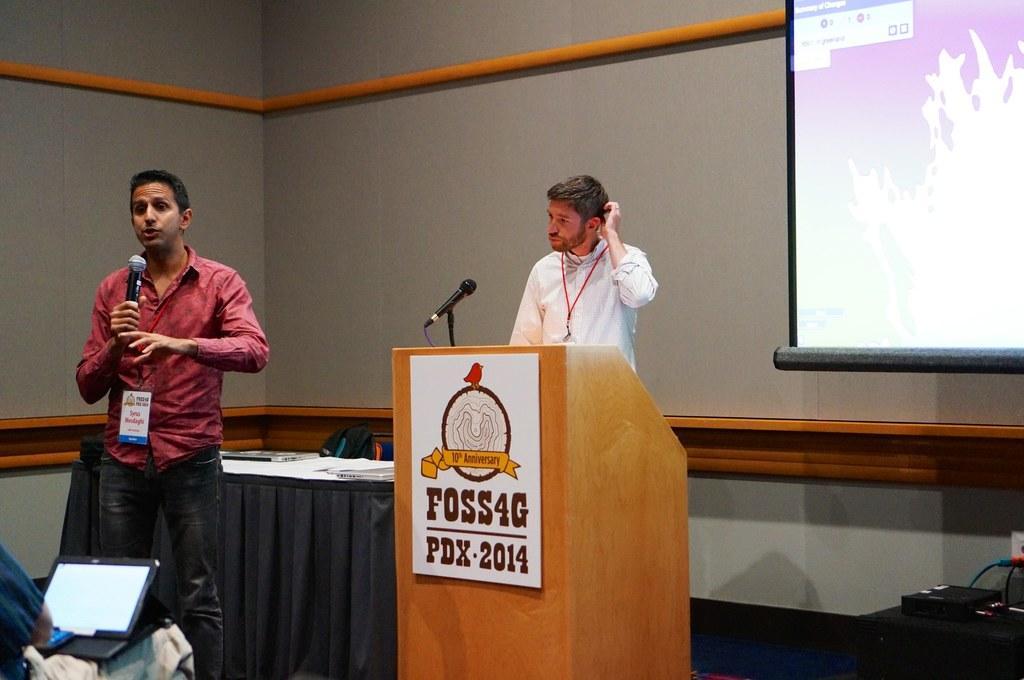How would you summarize this image in a sentence or two? In the bottom left corner of the image a man is sitting and holding a laptop. In front of him a man is standing and holding a microphone. Behind him we can see a table and podium, on the table we can see some papers, on the podium we can see a microphone. Behind them a person is standing and there are some bags. At the top of the image we can see a wall, on the wall we can see a screen. In the bottom right corner of the image we can see a table, on the table we can see some electronic devices. 